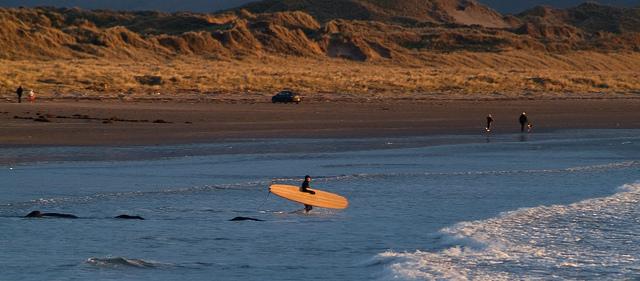Should this man's friends find him easier to spot than most?
Be succinct. Yes. Where is the man?
Write a very short answer. In water. What sport is the man doing?
Quick response, please. Surfing. 